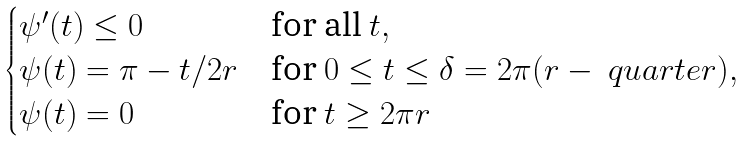<formula> <loc_0><loc_0><loc_500><loc_500>\begin{cases} \psi ^ { \prime } ( t ) \leq 0 & \text {for all } t , \\ \psi ( t ) = \pi - t / 2 r & \text {for } 0 \leq t \leq \delta = 2 \pi ( r - \ q u a r t e r ) , \\ \psi ( t ) = 0 & \text {for } t \geq 2 \pi r \end{cases}</formula> 